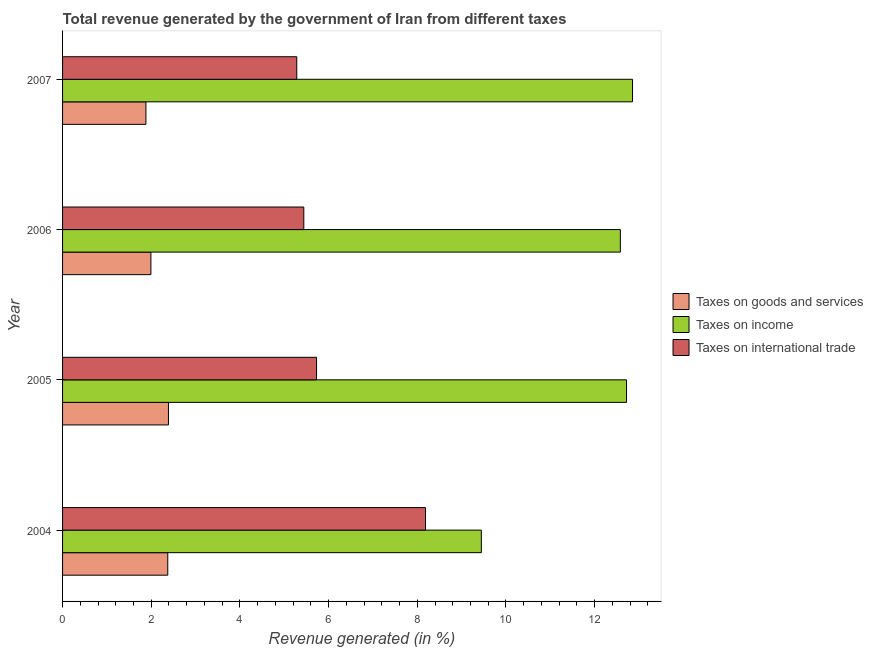How many groups of bars are there?
Offer a very short reply. 4. How many bars are there on the 1st tick from the bottom?
Offer a terse response. 3. What is the label of the 4th group of bars from the top?
Your response must be concise. 2004. What is the percentage of revenue generated by taxes on goods and services in 2007?
Your answer should be very brief. 1.88. Across all years, what is the maximum percentage of revenue generated by taxes on goods and services?
Make the answer very short. 2.39. Across all years, what is the minimum percentage of revenue generated by taxes on income?
Your response must be concise. 9.45. In which year was the percentage of revenue generated by tax on international trade maximum?
Your answer should be very brief. 2004. In which year was the percentage of revenue generated by taxes on goods and services minimum?
Give a very brief answer. 2007. What is the total percentage of revenue generated by taxes on income in the graph?
Ensure brevity in your answer.  47.6. What is the difference between the percentage of revenue generated by taxes on goods and services in 2005 and that in 2007?
Offer a terse response. 0.51. What is the difference between the percentage of revenue generated by taxes on goods and services in 2007 and the percentage of revenue generated by tax on international trade in 2004?
Your answer should be compact. -6.31. What is the average percentage of revenue generated by taxes on income per year?
Make the answer very short. 11.9. In the year 2006, what is the difference between the percentage of revenue generated by tax on international trade and percentage of revenue generated by taxes on goods and services?
Give a very brief answer. 3.45. What is the ratio of the percentage of revenue generated by taxes on income in 2004 to that in 2006?
Provide a succinct answer. 0.75. Is the difference between the percentage of revenue generated by taxes on income in 2004 and 2007 greater than the difference between the percentage of revenue generated by tax on international trade in 2004 and 2007?
Offer a terse response. No. What is the difference between the highest and the second highest percentage of revenue generated by tax on international trade?
Offer a terse response. 2.46. What is the difference between the highest and the lowest percentage of revenue generated by taxes on goods and services?
Make the answer very short. 0.51. In how many years, is the percentage of revenue generated by taxes on goods and services greater than the average percentage of revenue generated by taxes on goods and services taken over all years?
Your answer should be compact. 2. What does the 3rd bar from the top in 2007 represents?
Provide a short and direct response. Taxes on goods and services. What does the 1st bar from the bottom in 2004 represents?
Offer a terse response. Taxes on goods and services. Is it the case that in every year, the sum of the percentage of revenue generated by taxes on goods and services and percentage of revenue generated by taxes on income is greater than the percentage of revenue generated by tax on international trade?
Provide a succinct answer. Yes. How many bars are there?
Your response must be concise. 12. What is the difference between two consecutive major ticks on the X-axis?
Your response must be concise. 2. Does the graph contain any zero values?
Give a very brief answer. No. How are the legend labels stacked?
Provide a short and direct response. Vertical. What is the title of the graph?
Offer a terse response. Total revenue generated by the government of Iran from different taxes. Does "Argument" appear as one of the legend labels in the graph?
Your answer should be very brief. No. What is the label or title of the X-axis?
Offer a terse response. Revenue generated (in %). What is the Revenue generated (in %) in Taxes on goods and services in 2004?
Your answer should be very brief. 2.37. What is the Revenue generated (in %) of Taxes on income in 2004?
Keep it short and to the point. 9.45. What is the Revenue generated (in %) of Taxes on international trade in 2004?
Ensure brevity in your answer.  8.19. What is the Revenue generated (in %) in Taxes on goods and services in 2005?
Ensure brevity in your answer.  2.39. What is the Revenue generated (in %) of Taxes on income in 2005?
Provide a succinct answer. 12.72. What is the Revenue generated (in %) in Taxes on international trade in 2005?
Give a very brief answer. 5.73. What is the Revenue generated (in %) in Taxes on goods and services in 2006?
Provide a short and direct response. 1.99. What is the Revenue generated (in %) in Taxes on income in 2006?
Offer a very short reply. 12.58. What is the Revenue generated (in %) in Taxes on international trade in 2006?
Offer a terse response. 5.44. What is the Revenue generated (in %) of Taxes on goods and services in 2007?
Offer a terse response. 1.88. What is the Revenue generated (in %) in Taxes on income in 2007?
Ensure brevity in your answer.  12.86. What is the Revenue generated (in %) in Taxes on international trade in 2007?
Offer a terse response. 5.28. Across all years, what is the maximum Revenue generated (in %) in Taxes on goods and services?
Keep it short and to the point. 2.39. Across all years, what is the maximum Revenue generated (in %) of Taxes on income?
Your answer should be compact. 12.86. Across all years, what is the maximum Revenue generated (in %) in Taxes on international trade?
Give a very brief answer. 8.19. Across all years, what is the minimum Revenue generated (in %) of Taxes on goods and services?
Provide a succinct answer. 1.88. Across all years, what is the minimum Revenue generated (in %) of Taxes on income?
Your answer should be very brief. 9.45. Across all years, what is the minimum Revenue generated (in %) in Taxes on international trade?
Ensure brevity in your answer.  5.28. What is the total Revenue generated (in %) of Taxes on goods and services in the graph?
Provide a succinct answer. 8.63. What is the total Revenue generated (in %) of Taxes on income in the graph?
Provide a succinct answer. 47.6. What is the total Revenue generated (in %) in Taxes on international trade in the graph?
Keep it short and to the point. 24.64. What is the difference between the Revenue generated (in %) in Taxes on goods and services in 2004 and that in 2005?
Give a very brief answer. -0.02. What is the difference between the Revenue generated (in %) of Taxes on income in 2004 and that in 2005?
Make the answer very short. -3.27. What is the difference between the Revenue generated (in %) in Taxes on international trade in 2004 and that in 2005?
Your response must be concise. 2.46. What is the difference between the Revenue generated (in %) in Taxes on goods and services in 2004 and that in 2006?
Make the answer very short. 0.38. What is the difference between the Revenue generated (in %) of Taxes on income in 2004 and that in 2006?
Your response must be concise. -3.14. What is the difference between the Revenue generated (in %) in Taxes on international trade in 2004 and that in 2006?
Keep it short and to the point. 2.74. What is the difference between the Revenue generated (in %) of Taxes on goods and services in 2004 and that in 2007?
Make the answer very short. 0.49. What is the difference between the Revenue generated (in %) in Taxes on income in 2004 and that in 2007?
Offer a terse response. -3.41. What is the difference between the Revenue generated (in %) of Taxes on international trade in 2004 and that in 2007?
Provide a short and direct response. 2.9. What is the difference between the Revenue generated (in %) of Taxes on goods and services in 2005 and that in 2006?
Offer a terse response. 0.4. What is the difference between the Revenue generated (in %) of Taxes on income in 2005 and that in 2006?
Offer a terse response. 0.14. What is the difference between the Revenue generated (in %) of Taxes on international trade in 2005 and that in 2006?
Give a very brief answer. 0.29. What is the difference between the Revenue generated (in %) in Taxes on goods and services in 2005 and that in 2007?
Your response must be concise. 0.51. What is the difference between the Revenue generated (in %) of Taxes on income in 2005 and that in 2007?
Your response must be concise. -0.14. What is the difference between the Revenue generated (in %) of Taxes on international trade in 2005 and that in 2007?
Your answer should be very brief. 0.45. What is the difference between the Revenue generated (in %) of Taxes on goods and services in 2006 and that in 2007?
Provide a succinct answer. 0.11. What is the difference between the Revenue generated (in %) of Taxes on income in 2006 and that in 2007?
Offer a very short reply. -0.27. What is the difference between the Revenue generated (in %) of Taxes on international trade in 2006 and that in 2007?
Give a very brief answer. 0.16. What is the difference between the Revenue generated (in %) in Taxes on goods and services in 2004 and the Revenue generated (in %) in Taxes on income in 2005?
Keep it short and to the point. -10.35. What is the difference between the Revenue generated (in %) of Taxes on goods and services in 2004 and the Revenue generated (in %) of Taxes on international trade in 2005?
Offer a terse response. -3.36. What is the difference between the Revenue generated (in %) of Taxes on income in 2004 and the Revenue generated (in %) of Taxes on international trade in 2005?
Your answer should be compact. 3.72. What is the difference between the Revenue generated (in %) of Taxes on goods and services in 2004 and the Revenue generated (in %) of Taxes on income in 2006?
Your response must be concise. -10.21. What is the difference between the Revenue generated (in %) of Taxes on goods and services in 2004 and the Revenue generated (in %) of Taxes on international trade in 2006?
Keep it short and to the point. -3.07. What is the difference between the Revenue generated (in %) of Taxes on income in 2004 and the Revenue generated (in %) of Taxes on international trade in 2006?
Offer a terse response. 4. What is the difference between the Revenue generated (in %) of Taxes on goods and services in 2004 and the Revenue generated (in %) of Taxes on income in 2007?
Ensure brevity in your answer.  -10.48. What is the difference between the Revenue generated (in %) of Taxes on goods and services in 2004 and the Revenue generated (in %) of Taxes on international trade in 2007?
Offer a very short reply. -2.91. What is the difference between the Revenue generated (in %) in Taxes on income in 2004 and the Revenue generated (in %) in Taxes on international trade in 2007?
Your answer should be very brief. 4.16. What is the difference between the Revenue generated (in %) of Taxes on goods and services in 2005 and the Revenue generated (in %) of Taxes on income in 2006?
Your answer should be very brief. -10.19. What is the difference between the Revenue generated (in %) in Taxes on goods and services in 2005 and the Revenue generated (in %) in Taxes on international trade in 2006?
Provide a short and direct response. -3.05. What is the difference between the Revenue generated (in %) in Taxes on income in 2005 and the Revenue generated (in %) in Taxes on international trade in 2006?
Your response must be concise. 7.28. What is the difference between the Revenue generated (in %) in Taxes on goods and services in 2005 and the Revenue generated (in %) in Taxes on income in 2007?
Make the answer very short. -10.47. What is the difference between the Revenue generated (in %) in Taxes on goods and services in 2005 and the Revenue generated (in %) in Taxes on international trade in 2007?
Your answer should be very brief. -2.89. What is the difference between the Revenue generated (in %) in Taxes on income in 2005 and the Revenue generated (in %) in Taxes on international trade in 2007?
Give a very brief answer. 7.44. What is the difference between the Revenue generated (in %) of Taxes on goods and services in 2006 and the Revenue generated (in %) of Taxes on income in 2007?
Offer a very short reply. -10.86. What is the difference between the Revenue generated (in %) of Taxes on goods and services in 2006 and the Revenue generated (in %) of Taxes on international trade in 2007?
Offer a very short reply. -3.29. What is the difference between the Revenue generated (in %) of Taxes on income in 2006 and the Revenue generated (in %) of Taxes on international trade in 2007?
Give a very brief answer. 7.3. What is the average Revenue generated (in %) of Taxes on goods and services per year?
Make the answer very short. 2.16. What is the average Revenue generated (in %) in Taxes on income per year?
Your answer should be compact. 11.9. What is the average Revenue generated (in %) of Taxes on international trade per year?
Keep it short and to the point. 6.16. In the year 2004, what is the difference between the Revenue generated (in %) in Taxes on goods and services and Revenue generated (in %) in Taxes on income?
Your answer should be compact. -7.07. In the year 2004, what is the difference between the Revenue generated (in %) in Taxes on goods and services and Revenue generated (in %) in Taxes on international trade?
Your answer should be compact. -5.81. In the year 2004, what is the difference between the Revenue generated (in %) of Taxes on income and Revenue generated (in %) of Taxes on international trade?
Provide a succinct answer. 1.26. In the year 2005, what is the difference between the Revenue generated (in %) in Taxes on goods and services and Revenue generated (in %) in Taxes on income?
Offer a terse response. -10.33. In the year 2005, what is the difference between the Revenue generated (in %) of Taxes on goods and services and Revenue generated (in %) of Taxes on international trade?
Your answer should be very brief. -3.34. In the year 2005, what is the difference between the Revenue generated (in %) of Taxes on income and Revenue generated (in %) of Taxes on international trade?
Keep it short and to the point. 6.99. In the year 2006, what is the difference between the Revenue generated (in %) of Taxes on goods and services and Revenue generated (in %) of Taxes on income?
Offer a very short reply. -10.59. In the year 2006, what is the difference between the Revenue generated (in %) of Taxes on goods and services and Revenue generated (in %) of Taxes on international trade?
Give a very brief answer. -3.45. In the year 2006, what is the difference between the Revenue generated (in %) of Taxes on income and Revenue generated (in %) of Taxes on international trade?
Ensure brevity in your answer.  7.14. In the year 2007, what is the difference between the Revenue generated (in %) of Taxes on goods and services and Revenue generated (in %) of Taxes on income?
Your response must be concise. -10.98. In the year 2007, what is the difference between the Revenue generated (in %) in Taxes on goods and services and Revenue generated (in %) in Taxes on international trade?
Offer a terse response. -3.4. In the year 2007, what is the difference between the Revenue generated (in %) in Taxes on income and Revenue generated (in %) in Taxes on international trade?
Your answer should be compact. 7.57. What is the ratio of the Revenue generated (in %) of Taxes on goods and services in 2004 to that in 2005?
Offer a terse response. 0.99. What is the ratio of the Revenue generated (in %) in Taxes on income in 2004 to that in 2005?
Your answer should be very brief. 0.74. What is the ratio of the Revenue generated (in %) in Taxes on international trade in 2004 to that in 2005?
Give a very brief answer. 1.43. What is the ratio of the Revenue generated (in %) in Taxes on goods and services in 2004 to that in 2006?
Offer a terse response. 1.19. What is the ratio of the Revenue generated (in %) in Taxes on income in 2004 to that in 2006?
Offer a terse response. 0.75. What is the ratio of the Revenue generated (in %) in Taxes on international trade in 2004 to that in 2006?
Your answer should be very brief. 1.5. What is the ratio of the Revenue generated (in %) in Taxes on goods and services in 2004 to that in 2007?
Offer a very short reply. 1.26. What is the ratio of the Revenue generated (in %) in Taxes on income in 2004 to that in 2007?
Offer a very short reply. 0.73. What is the ratio of the Revenue generated (in %) in Taxes on international trade in 2004 to that in 2007?
Offer a terse response. 1.55. What is the ratio of the Revenue generated (in %) of Taxes on goods and services in 2005 to that in 2006?
Your response must be concise. 1.2. What is the ratio of the Revenue generated (in %) of Taxes on income in 2005 to that in 2006?
Offer a very short reply. 1.01. What is the ratio of the Revenue generated (in %) of Taxes on international trade in 2005 to that in 2006?
Your answer should be compact. 1.05. What is the ratio of the Revenue generated (in %) in Taxes on goods and services in 2005 to that in 2007?
Keep it short and to the point. 1.27. What is the ratio of the Revenue generated (in %) of Taxes on income in 2005 to that in 2007?
Ensure brevity in your answer.  0.99. What is the ratio of the Revenue generated (in %) of Taxes on international trade in 2005 to that in 2007?
Give a very brief answer. 1.08. What is the ratio of the Revenue generated (in %) of Taxes on goods and services in 2006 to that in 2007?
Provide a short and direct response. 1.06. What is the ratio of the Revenue generated (in %) of Taxes on income in 2006 to that in 2007?
Your answer should be compact. 0.98. What is the ratio of the Revenue generated (in %) in Taxes on international trade in 2006 to that in 2007?
Offer a very short reply. 1.03. What is the difference between the highest and the second highest Revenue generated (in %) in Taxes on goods and services?
Ensure brevity in your answer.  0.02. What is the difference between the highest and the second highest Revenue generated (in %) of Taxes on income?
Provide a short and direct response. 0.14. What is the difference between the highest and the second highest Revenue generated (in %) in Taxes on international trade?
Keep it short and to the point. 2.46. What is the difference between the highest and the lowest Revenue generated (in %) of Taxes on goods and services?
Your response must be concise. 0.51. What is the difference between the highest and the lowest Revenue generated (in %) in Taxes on income?
Your answer should be compact. 3.41. What is the difference between the highest and the lowest Revenue generated (in %) of Taxes on international trade?
Make the answer very short. 2.9. 